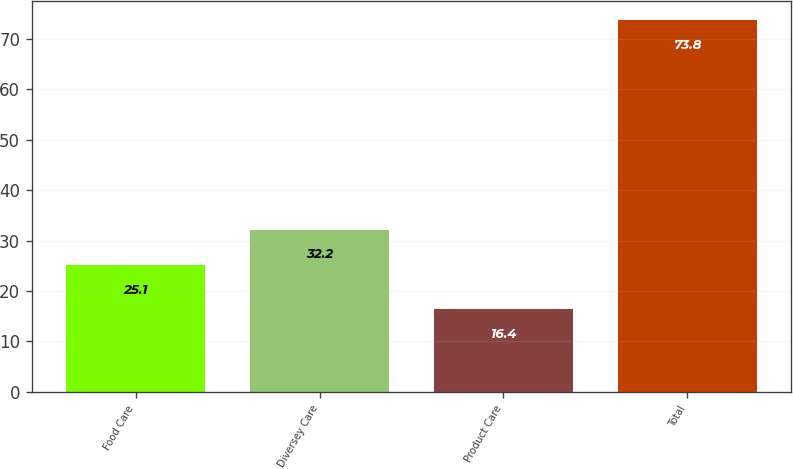Convert chart. <chart><loc_0><loc_0><loc_500><loc_500><bar_chart><fcel>Food Care<fcel>Diversey Care<fcel>Product Care<fcel>Total<nl><fcel>25.1<fcel>32.2<fcel>16.4<fcel>73.8<nl></chart> 